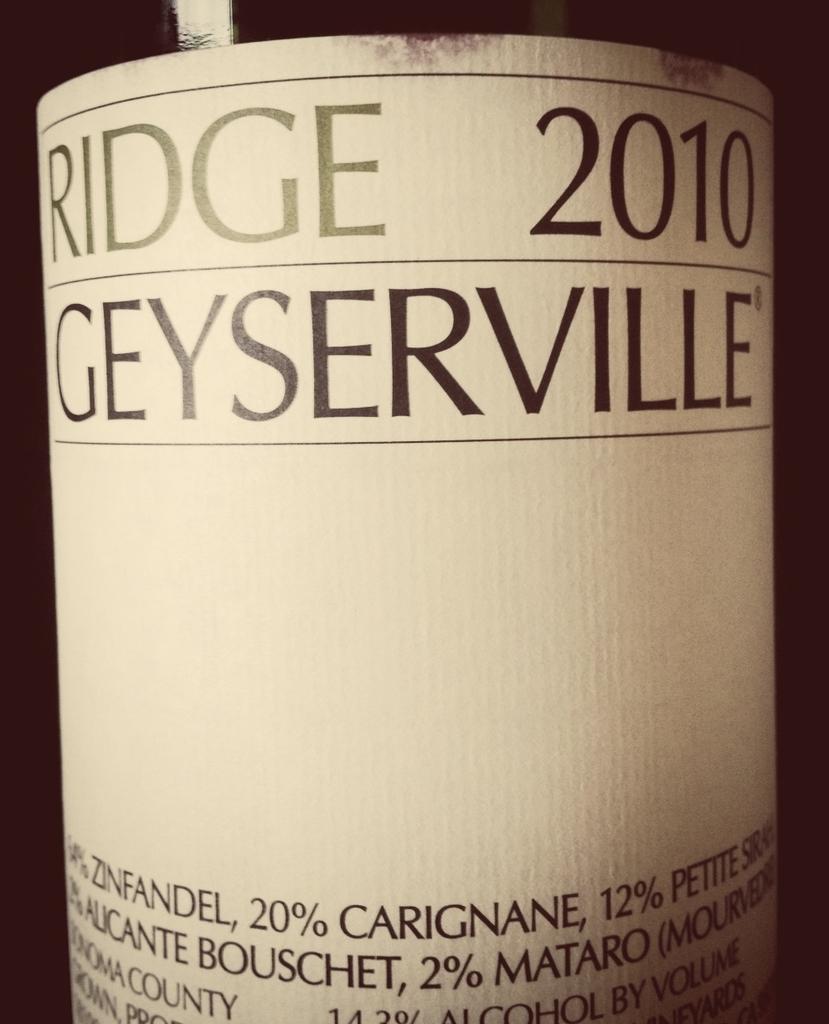What year is this bottle?
Your answer should be very brief. 2010. 